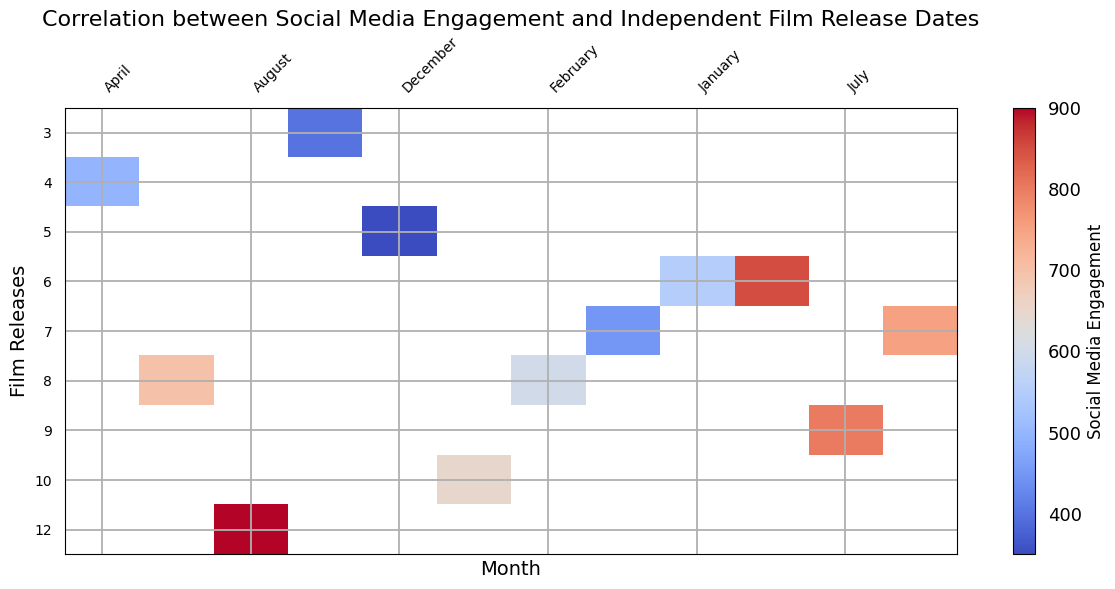What's the month with the highest social media engagement? Look for the column with the most intense color for social media engagement. December shows the highest intensity.
Answer: December Which month has the least number of film releases and how does its social media engagement compare? Look for the month with the shortest bar in the 'Film Releases' axis, which is February with 3 releases. Then check its social media engagement, which is 400.
Answer: February, 400 Does July have higher social media engagement than June? Compare the color intensity of the July and June columns. July's color is more intense, indicating higher social media engagement.
Answer: Yes Identify the month(s) where social media engagement is between 650 and 700. Look for columns with colors indicating social media engagement values between 650 and 700. Those months are July (650) and August (700).
Answer: July and August What is the difference in social media engagement between November and May? Check the values for November (850) and May (550). The difference is 850 - 550 = 300.
Answer: 300 What is the average social media engagement from March to May? Sum the engagements from March (450), April (500), and May (550), and divide by 3: (450 + 500 + 550) / 3 = 500.
Answer: 500 Which month has the most number of film releases? Identify the longest bar in the 'Film Releases' axis. December has the longest bar with 12 releases.
Answer: December Between January and March, which month has the highest social media engagement, and by how much? Compare the colors of January (350), February (400), and March (450). March has the highest, which is 450. The difference with the next highest (February) is 450 - 400 = 50.
Answer: March, 50 How does social media engagement in October compare to the average engagement from July to September? October has an engagement of 800. The average engagement for July (650), August (700), and September (750) is (650 + 700 + 750) / 3 = 700. 800 is higher than 700.
Answer: October's engagement is higher Which month exhibits the steepest increase in social media engagement compared to the preceding month? Calculate the differences between each consecutive month and find the greatest increase. From September (750) to October (800) is an increase of 50, which is not the steepest compared to November to December. The steepest is from November (850) to December (900) = 50.
Answer: November to December 